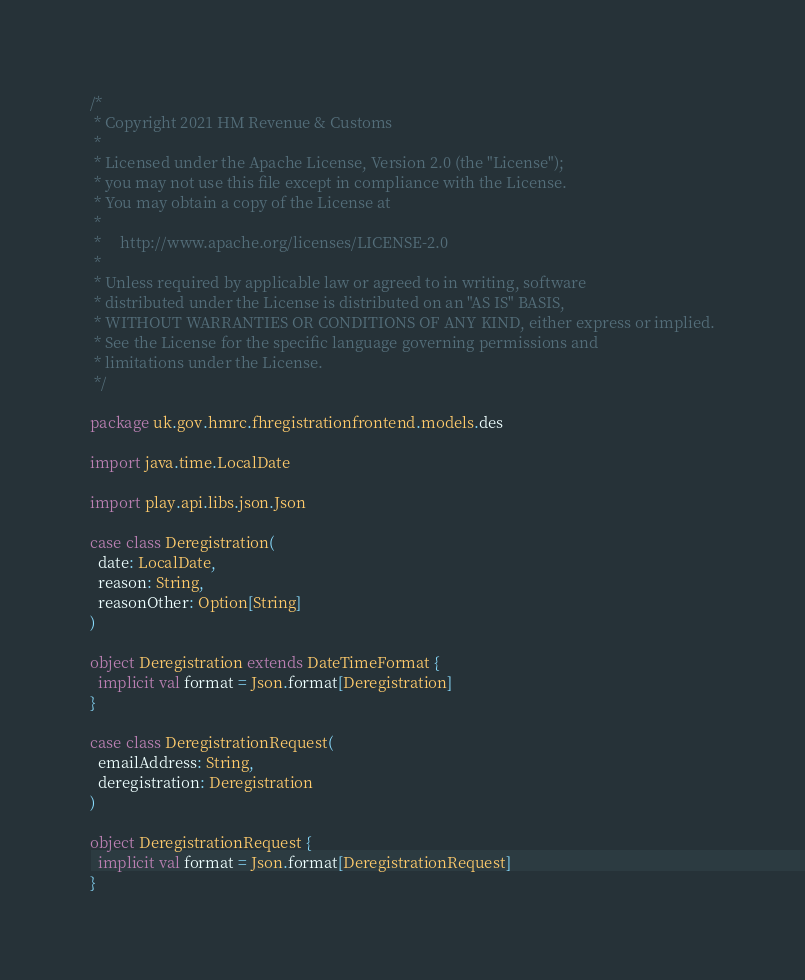Convert code to text. <code><loc_0><loc_0><loc_500><loc_500><_Scala_>/*
 * Copyright 2021 HM Revenue & Customs
 *
 * Licensed under the Apache License, Version 2.0 (the "License");
 * you may not use this file except in compliance with the License.
 * You may obtain a copy of the License at
 *
 *     http://www.apache.org/licenses/LICENSE-2.0
 *
 * Unless required by applicable law or agreed to in writing, software
 * distributed under the License is distributed on an "AS IS" BASIS,
 * WITHOUT WARRANTIES OR CONDITIONS OF ANY KIND, either express or implied.
 * See the License for the specific language governing permissions and
 * limitations under the License.
 */

package uk.gov.hmrc.fhregistrationfrontend.models.des

import java.time.LocalDate

import play.api.libs.json.Json

case class Deregistration(
  date: LocalDate,
  reason: String,
  reasonOther: Option[String]
)

object Deregistration extends DateTimeFormat {
  implicit val format = Json.format[Deregistration]
}

case class DeregistrationRequest(
  emailAddress: String,
  deregistration: Deregistration
)

object DeregistrationRequest {
  implicit val format = Json.format[DeregistrationRequest]
}
</code> 